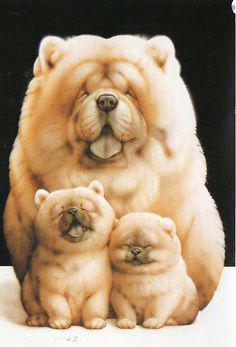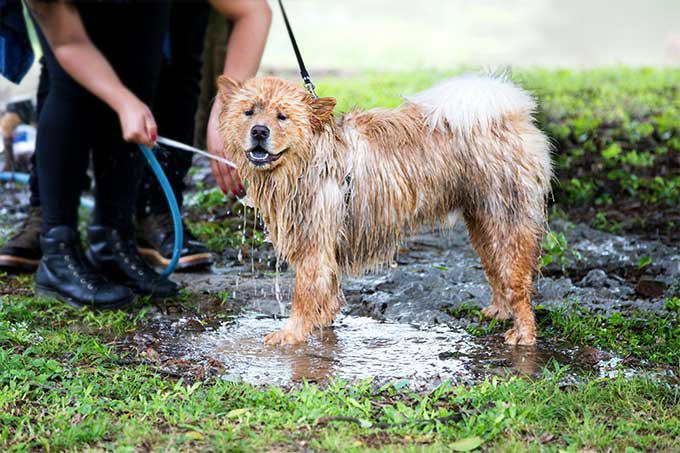The first image is the image on the left, the second image is the image on the right. Considering the images on both sides, is "There are two dogs" valid? Answer yes or no. No. The first image is the image on the left, the second image is the image on the right. Assess this claim about the two images: "Two young chows are side-by-side in one of the images.". Correct or not? Answer yes or no. Yes. 